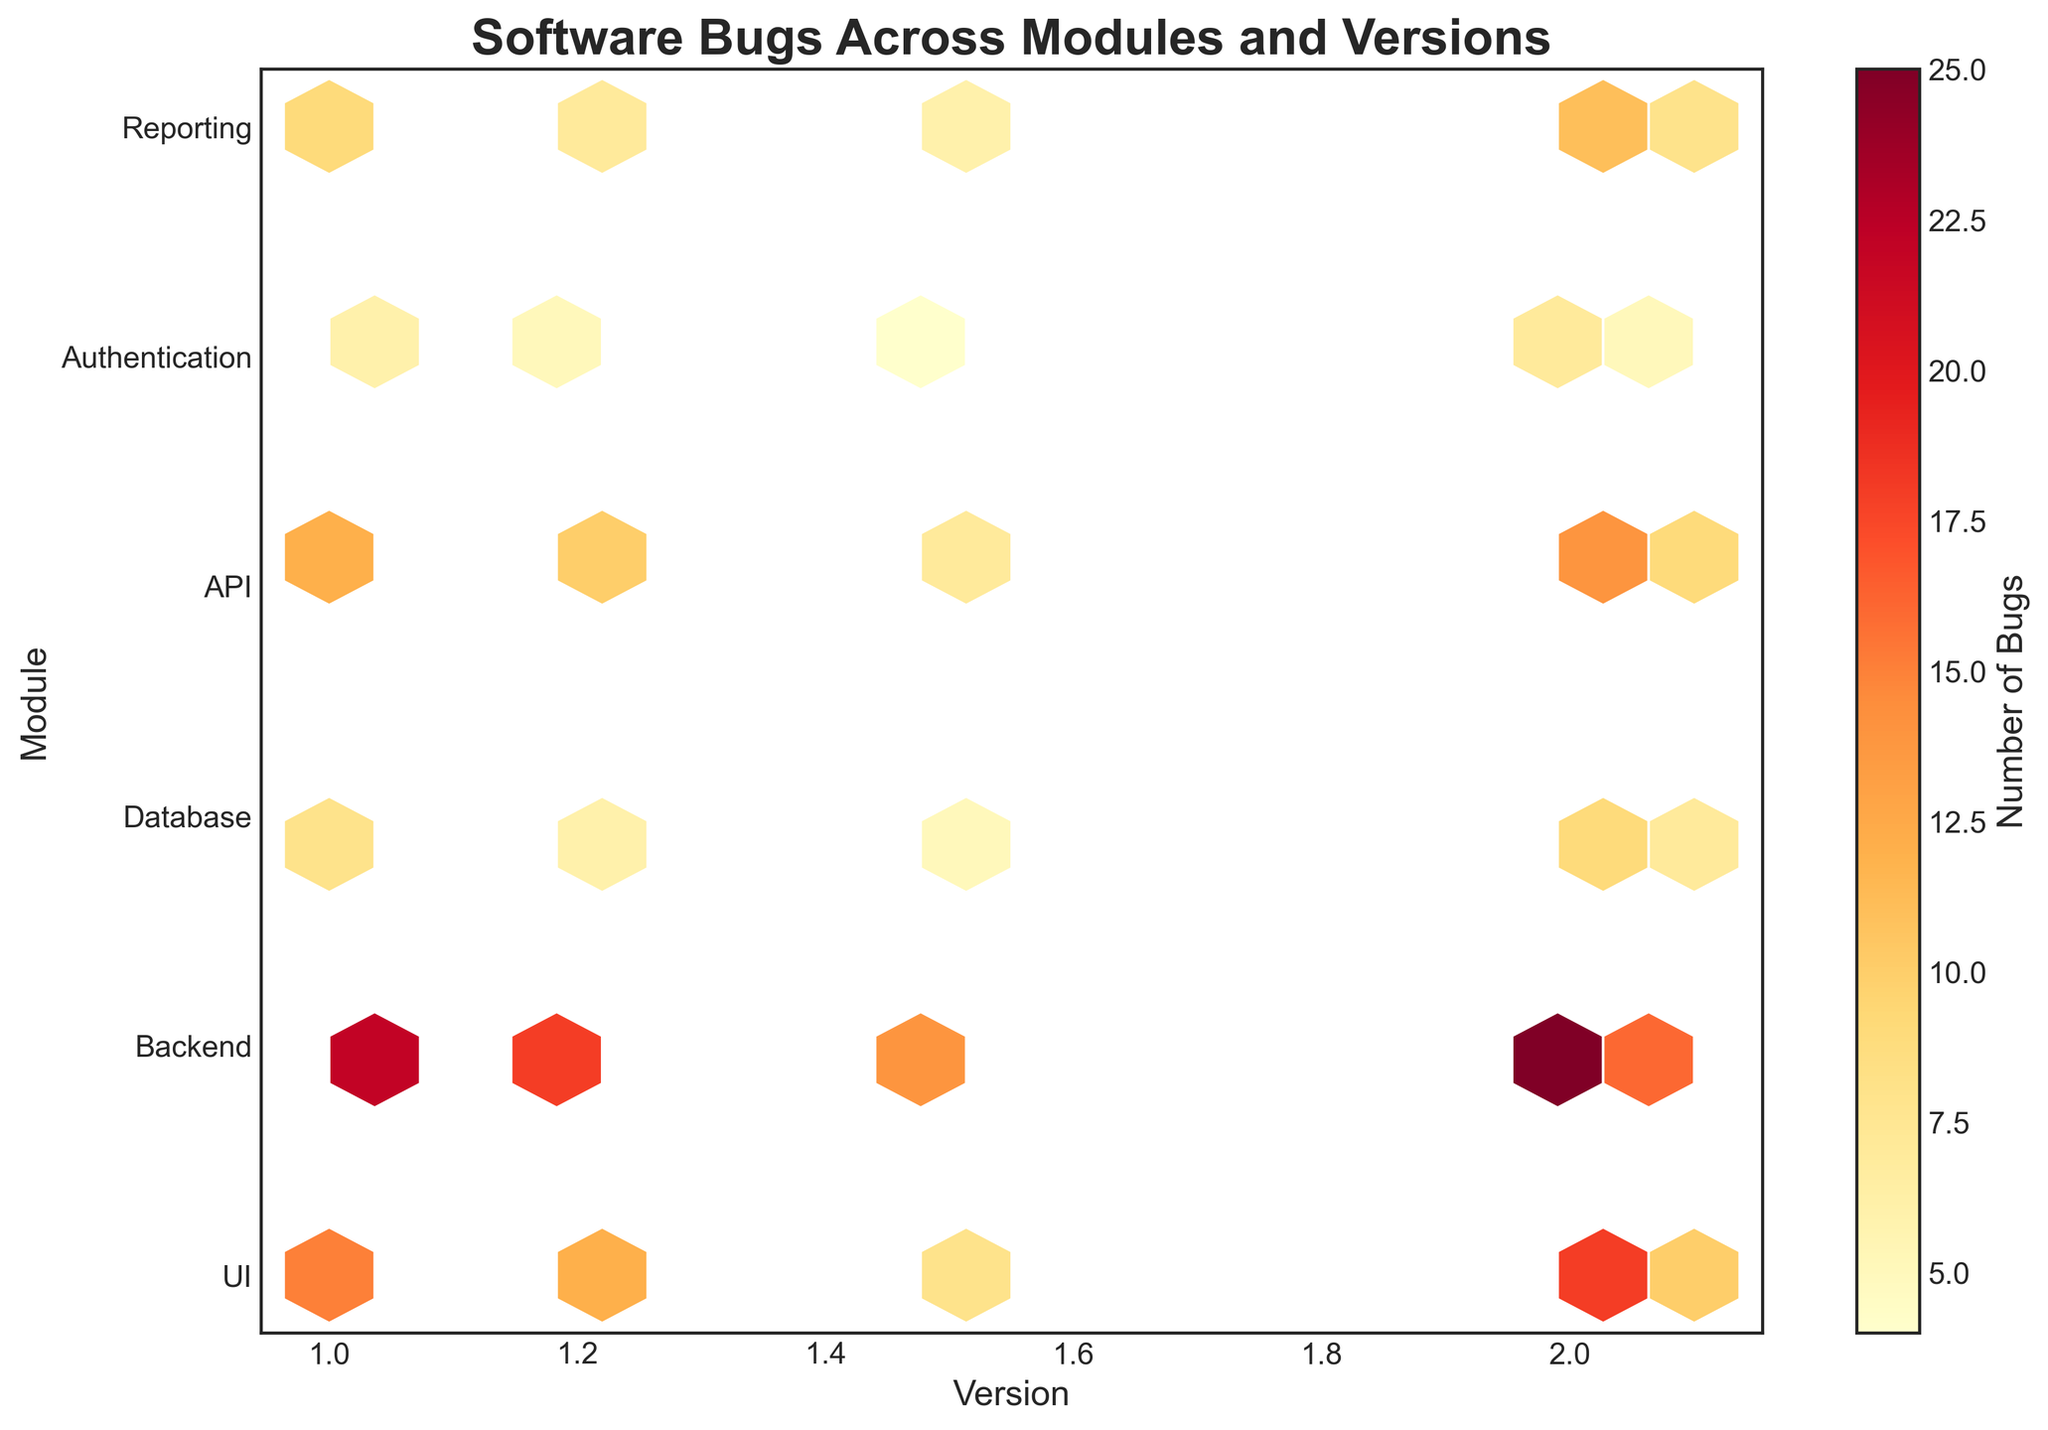What is the title of the hexbin plot? The title of the plot is the text displayed at the top of the figure which describes the main idea of the visualization. In this plot, the title summarizes the focus of the analysis.
Answer: Software Bugs Across Modules and Versions Which module has the highest number of bugs in version 1.0? To find the module with the highest number of bugs in a specific version, observe the color density of different hexagons corresponding to that version. The hexagon with the darkest shade represents the highest number of bugs. In version 1.0, the Backend module has the darkest shade.
Answer: Backend How do the number of bugs in the UI module for version 2.0 compare to version 1.5? To compare the number of bugs between two versions for the UI module, look for the hexagons corresponding to these module-version pairs. Compare the color shades; a darker hexagon indicates more bugs. The UI module has a darker hexagon in version 2.0 compared to version 1.5.
Answer: Higher in version 2.0 Which module shows the least variation in the number of bugs across different versions? To determine the module with the least variation, observe the color shades of the hexagons for each module across different versions. The module with the most consistent shades of color across the versions shows the least variation.
Answer: Authentication What version has the lowest average number of bugs across all modules? To find the version with the lowest average number of bugs, observe the color shades of the hexagons for each version across all modules. The version with the lighter overall color shades indicates the lowest average number of bugs.
Answer: Version 1.5 How has the number of bugs in the Backend module changed from version 1.0 to version 2.1? Identify the hexagons corresponding to the Backend module in versions 1.0 and 2.1. Note the color shade change; a darker shade over time indicates an increase in the number of bugs, while a lighter shade indicates a decrease. The hexagon for Backend has lightened slightly from version 1.0 to 2.1.
Answer: Decreased Are the bugs evenly distributed across all modules in version 2.0? To determine this, observe the color shades of the hexagons for all modules in version 2.0. Even distribution would mean similar color shades across all modules. The color shades vary widely among modules, indicating an uneven distribution.
Answer: No Which version shows the highest density of bugs in the API module? Look for the hexagon corresponding to the API module in different versions and observe the color shades. The version with the darkest hexagon has the highest density of bugs.
Answer: Version 2.0 